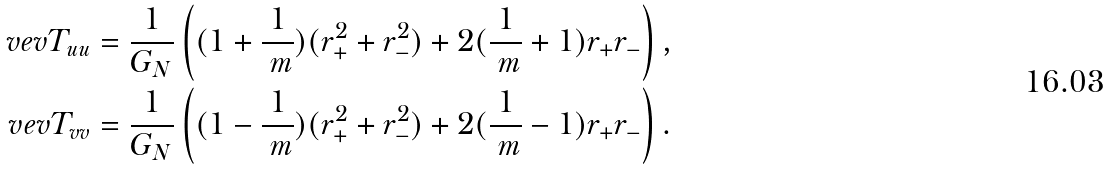Convert formula to latex. <formula><loc_0><loc_0><loc_500><loc_500>\ v e v { T _ { u u } } & = \frac { 1 } { G _ { N } } \left ( ( 1 + \frac { 1 } { \ m } ) ( r _ { + } ^ { 2 } + r _ { - } ^ { 2 } ) + 2 ( \frac { 1 } { \ m } + 1 ) r _ { + } r _ { - } \right ) , \\ \ v e v { T _ { v v } } & = \frac { 1 } { G _ { N } } \left ( ( 1 - \frac { 1 } { \ m } ) ( r _ { + } ^ { 2 } + r _ { - } ^ { 2 } ) + 2 ( \frac { 1 } { \ m } - 1 ) r _ { + } r _ { - } \right ) . \\</formula> 